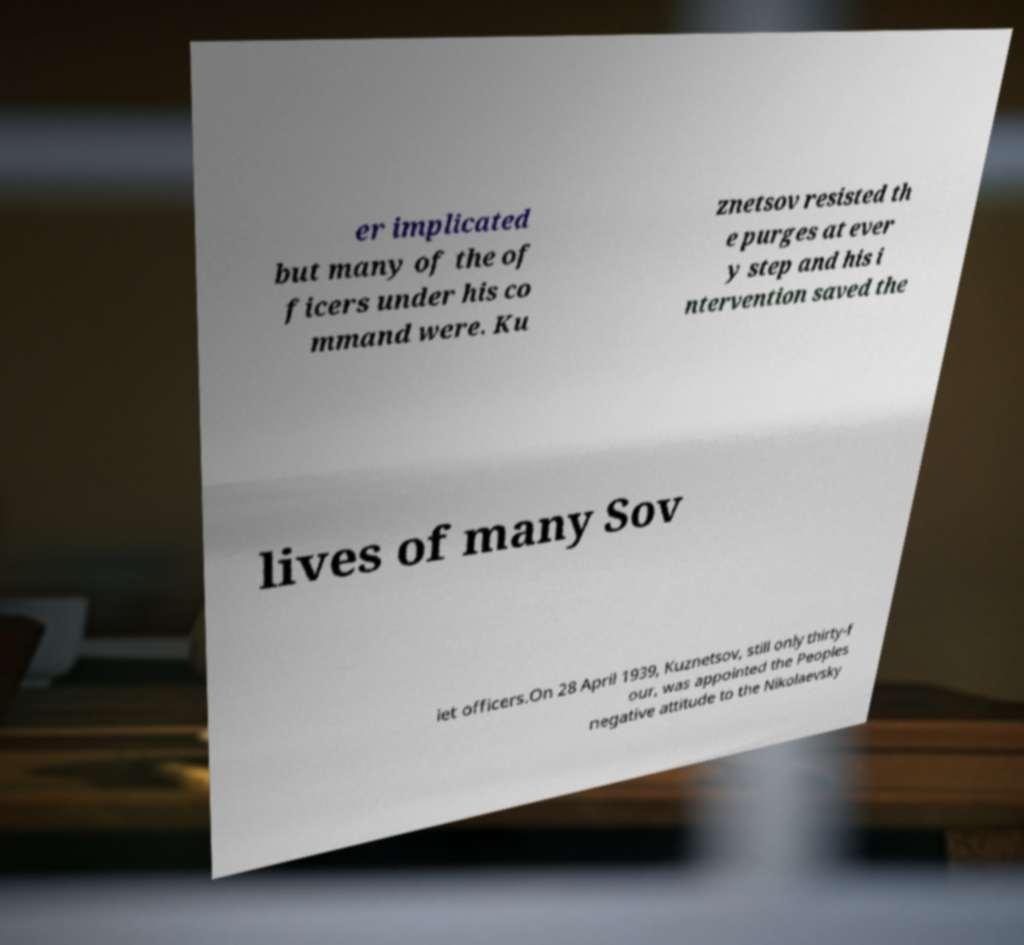Can you read and provide the text displayed in the image?This photo seems to have some interesting text. Can you extract and type it out for me? er implicated but many of the of ficers under his co mmand were. Ku znetsov resisted th e purges at ever y step and his i ntervention saved the lives of many Sov iet officers.On 28 April 1939, Kuznetsov, still only thirty-f our, was appointed the Peoples negative attitude to the Nikolaevsky 